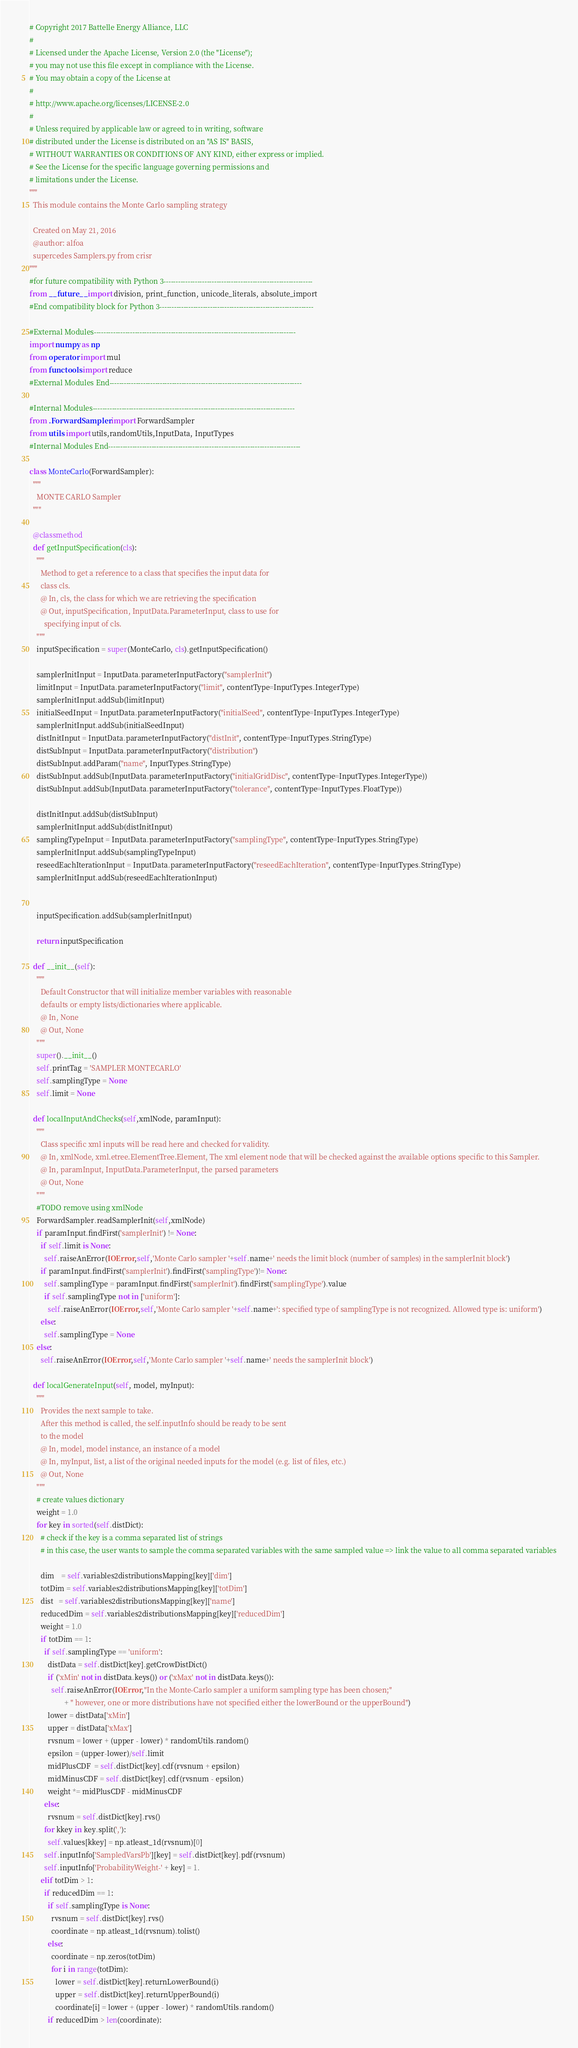Convert code to text. <code><loc_0><loc_0><loc_500><loc_500><_Python_># Copyright 2017 Battelle Energy Alliance, LLC
#
# Licensed under the Apache License, Version 2.0 (the "License");
# you may not use this file except in compliance with the License.
# You may obtain a copy of the License at
#
# http://www.apache.org/licenses/LICENSE-2.0
#
# Unless required by applicable law or agreed to in writing, software
# distributed under the License is distributed on an "AS IS" BASIS,
# WITHOUT WARRANTIES OR CONDITIONS OF ANY KIND, either express or implied.
# See the License for the specific language governing permissions and
# limitations under the License.
"""
  This module contains the Monte Carlo sampling strategy

  Created on May 21, 2016
  @author: alfoa
  supercedes Samplers.py from crisr
"""
#for future compatibility with Python 3--------------------------------------------------------------
from __future__ import division, print_function, unicode_literals, absolute_import
#End compatibility block for Python 3----------------------------------------------------------------

#External Modules------------------------------------------------------------------------------------
import numpy as np
from operator import mul
from functools import reduce
#External Modules End--------------------------------------------------------------------------------

#Internal Modules------------------------------------------------------------------------------------
from .ForwardSampler import ForwardSampler
from utils import utils,randomUtils,InputData, InputTypes
#Internal Modules End--------------------------------------------------------------------------------

class MonteCarlo(ForwardSampler):
  """
    MONTE CARLO Sampler
  """

  @classmethod
  def getInputSpecification(cls):
    """
      Method to get a reference to a class that specifies the input data for
      class cls.
      @ In, cls, the class for which we are retrieving the specification
      @ Out, inputSpecification, InputData.ParameterInput, class to use for
        specifying input of cls.
    """
    inputSpecification = super(MonteCarlo, cls).getInputSpecification()

    samplerInitInput = InputData.parameterInputFactory("samplerInit")
    limitInput = InputData.parameterInputFactory("limit", contentType=InputTypes.IntegerType)
    samplerInitInput.addSub(limitInput)
    initialSeedInput = InputData.parameterInputFactory("initialSeed", contentType=InputTypes.IntegerType)
    samplerInitInput.addSub(initialSeedInput)
    distInitInput = InputData.parameterInputFactory("distInit", contentType=InputTypes.StringType)
    distSubInput = InputData.parameterInputFactory("distribution")
    distSubInput.addParam("name", InputTypes.StringType)
    distSubInput.addSub(InputData.parameterInputFactory("initialGridDisc", contentType=InputTypes.IntegerType))
    distSubInput.addSub(InputData.parameterInputFactory("tolerance", contentType=InputTypes.FloatType))

    distInitInput.addSub(distSubInput)
    samplerInitInput.addSub(distInitInput)
    samplingTypeInput = InputData.parameterInputFactory("samplingType", contentType=InputTypes.StringType)
    samplerInitInput.addSub(samplingTypeInput)
    reseedEachIterationInput = InputData.parameterInputFactory("reseedEachIteration", contentType=InputTypes.StringType)
    samplerInitInput.addSub(reseedEachIterationInput)


    inputSpecification.addSub(samplerInitInput)

    return inputSpecification

  def __init__(self):
    """
      Default Constructor that will initialize member variables with reasonable
      defaults or empty lists/dictionaries where applicable.
      @ In, None
      @ Out, None
    """
    super().__init__()
    self.printTag = 'SAMPLER MONTECARLO'
    self.samplingType = None
    self.limit = None

  def localInputAndChecks(self,xmlNode, paramInput):
    """
      Class specific xml inputs will be read here and checked for validity.
      @ In, xmlNode, xml.etree.ElementTree.Element, The xml element node that will be checked against the available options specific to this Sampler.
      @ In, paramInput, InputData.ParameterInput, the parsed parameters
      @ Out, None
    """
    #TODO remove using xmlNode
    ForwardSampler.readSamplerInit(self,xmlNode)
    if paramInput.findFirst('samplerInit') != None:
      if self.limit is None:
        self.raiseAnError(IOError,self,'Monte Carlo sampler '+self.name+' needs the limit block (number of samples) in the samplerInit block')
      if paramInput.findFirst('samplerInit').findFirst('samplingType')!= None:
        self.samplingType = paramInput.findFirst('samplerInit').findFirst('samplingType').value
        if self.samplingType not in ['uniform']:
          self.raiseAnError(IOError,self,'Monte Carlo sampler '+self.name+': specified type of samplingType is not recognized. Allowed type is: uniform')
      else:
        self.samplingType = None
    else:
      self.raiseAnError(IOError,self,'Monte Carlo sampler '+self.name+' needs the samplerInit block')

  def localGenerateInput(self, model, myInput):
    """
      Provides the next sample to take.
      After this method is called, the self.inputInfo should be ready to be sent
      to the model
      @ In, model, model instance, an instance of a model
      @ In, myInput, list, a list of the original needed inputs for the model (e.g. list of files, etc.)
      @ Out, None
    """
    # create values dictionary
    weight = 1.0
    for key in sorted(self.distDict):
      # check if the key is a comma separated list of strings
      # in this case, the user wants to sample the comma separated variables with the same sampled value => link the value to all comma separated variables

      dim    = self.variables2distributionsMapping[key]['dim']
      totDim = self.variables2distributionsMapping[key]['totDim']
      dist   = self.variables2distributionsMapping[key]['name']
      reducedDim = self.variables2distributionsMapping[key]['reducedDim']
      weight = 1.0
      if totDim == 1:
        if self.samplingType == 'uniform':
          distData = self.distDict[key].getCrowDistDict()
          if ('xMin' not in distData.keys()) or ('xMax' not in distData.keys()):
            self.raiseAnError(IOError,"In the Monte-Carlo sampler a uniform sampling type has been chosen;"
                   + " however, one or more distributions have not specified either the lowerBound or the upperBound")
          lower = distData['xMin']
          upper = distData['xMax']
          rvsnum = lower + (upper - lower) * randomUtils.random()
          epsilon = (upper-lower)/self.limit
          midPlusCDF  = self.distDict[key].cdf(rvsnum + epsilon)
          midMinusCDF = self.distDict[key].cdf(rvsnum - epsilon)
          weight *= midPlusCDF - midMinusCDF
        else:
          rvsnum = self.distDict[key].rvs()
        for kkey in key.split(','):
          self.values[kkey] = np.atleast_1d(rvsnum)[0]
        self.inputInfo['SampledVarsPb'][key] = self.distDict[key].pdf(rvsnum)
        self.inputInfo['ProbabilityWeight-' + key] = 1.
      elif totDim > 1:
        if reducedDim == 1:
          if self.samplingType is None:
            rvsnum = self.distDict[key].rvs()
            coordinate = np.atleast_1d(rvsnum).tolist()
          else:
            coordinate = np.zeros(totDim)
            for i in range(totDim):
              lower = self.distDict[key].returnLowerBound(i)
              upper = self.distDict[key].returnUpperBound(i)
              coordinate[i] = lower + (upper - lower) * randomUtils.random()
          if reducedDim > len(coordinate):</code> 